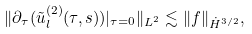Convert formula to latex. <formula><loc_0><loc_0><loc_500><loc_500>\| \partial _ { \tau } ( \tilde { u } _ { l } ^ { ( 2 ) } ( \tau , s ) ) | _ { \tau = 0 } \| _ { L ^ { 2 } } \lesssim \| f \| _ { \dot { H } ^ { 3 / 2 } } ,</formula> 